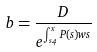Convert formula to latex. <formula><loc_0><loc_0><loc_500><loc_500>b = \frac { D } { e ^ { \int _ { s _ { 4 } } ^ { x } P ( s ) w s } }</formula> 